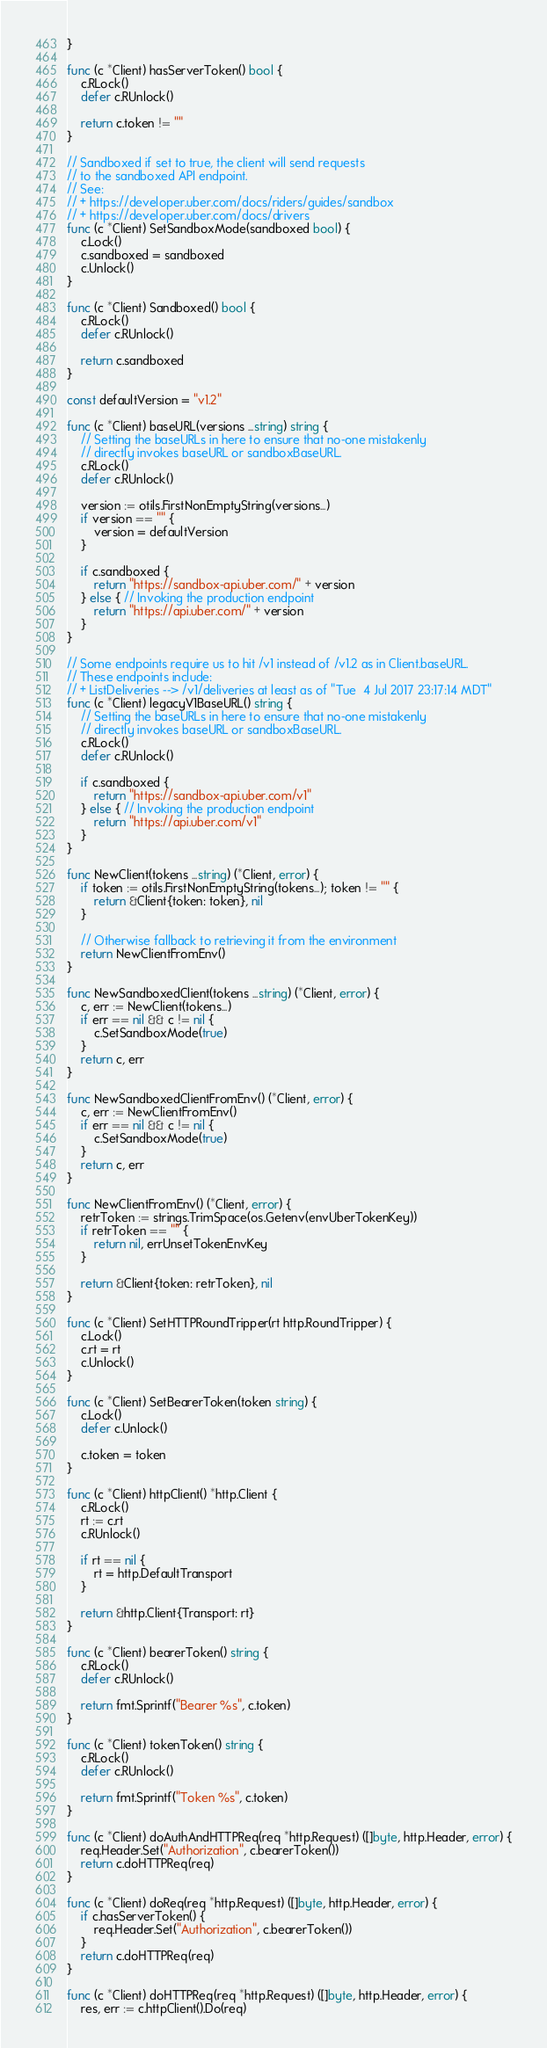<code> <loc_0><loc_0><loc_500><loc_500><_Go_>}

func (c *Client) hasServerToken() bool {
	c.RLock()
	defer c.RUnlock()

	return c.token != ""
}

// Sandboxed if set to true, the client will send requests
// to the sandboxed API endpoint.
// See:
// + https://developer.uber.com/docs/riders/guides/sandbox
// + https://developer.uber.com/docs/drivers
func (c *Client) SetSandboxMode(sandboxed bool) {
	c.Lock()
	c.sandboxed = sandboxed
	c.Unlock()
}

func (c *Client) Sandboxed() bool {
	c.RLock()
	defer c.RUnlock()

	return c.sandboxed
}

const defaultVersion = "v1.2"

func (c *Client) baseURL(versions ...string) string {
	// Setting the baseURLs in here to ensure that no-one mistakenly
	// directly invokes baseURL or sandboxBaseURL.
	c.RLock()
	defer c.RUnlock()

	version := otils.FirstNonEmptyString(versions...)
	if version == "" {
		version = defaultVersion
	}

	if c.sandboxed {
		return "https://sandbox-api.uber.com/" + version
	} else { // Invoking the production endpoint
		return "https://api.uber.com/" + version
	}
}

// Some endpoints require us to hit /v1 instead of /v1.2 as in Client.baseURL.
// These endpoints include:
// + ListDeliveries --> /v1/deliveries at least as of "Tue  4 Jul 2017 23:17:14 MDT"
func (c *Client) legacyV1BaseURL() string {
	// Setting the baseURLs in here to ensure that no-one mistakenly
	// directly invokes baseURL or sandboxBaseURL.
	c.RLock()
	defer c.RUnlock()

	if c.sandboxed {
		return "https://sandbox-api.uber.com/v1"
	} else { // Invoking the production endpoint
		return "https://api.uber.com/v1"
	}
}

func NewClient(tokens ...string) (*Client, error) {
	if token := otils.FirstNonEmptyString(tokens...); token != "" {
		return &Client{token: token}, nil
	}

	// Otherwise fallback to retrieving it from the environment
	return NewClientFromEnv()
}

func NewSandboxedClient(tokens ...string) (*Client, error) {
	c, err := NewClient(tokens...)
	if err == nil && c != nil {
		c.SetSandboxMode(true)
	}
	return c, err
}

func NewSandboxedClientFromEnv() (*Client, error) {
	c, err := NewClientFromEnv()
	if err == nil && c != nil {
		c.SetSandboxMode(true)
	}
	return c, err
}

func NewClientFromEnv() (*Client, error) {
	retrToken := strings.TrimSpace(os.Getenv(envUberTokenKey))
	if retrToken == "" {
		return nil, errUnsetTokenEnvKey
	}

	return &Client{token: retrToken}, nil
}

func (c *Client) SetHTTPRoundTripper(rt http.RoundTripper) {
	c.Lock()
	c.rt = rt
	c.Unlock()
}

func (c *Client) SetBearerToken(token string) {
	c.Lock()
	defer c.Unlock()

	c.token = token
}

func (c *Client) httpClient() *http.Client {
	c.RLock()
	rt := c.rt
	c.RUnlock()

	if rt == nil {
		rt = http.DefaultTransport
	}

	return &http.Client{Transport: rt}
}

func (c *Client) bearerToken() string {
	c.RLock()
	defer c.RUnlock()

	return fmt.Sprintf("Bearer %s", c.token)
}

func (c *Client) tokenToken() string {
	c.RLock()
	defer c.RUnlock()

	return fmt.Sprintf("Token %s", c.token)
}

func (c *Client) doAuthAndHTTPReq(req *http.Request) ([]byte, http.Header, error) {
	req.Header.Set("Authorization", c.bearerToken())
	return c.doHTTPReq(req)
}

func (c *Client) doReq(req *http.Request) ([]byte, http.Header, error) {
	if c.hasServerToken() {
		req.Header.Set("Authorization", c.bearerToken())
	}
	return c.doHTTPReq(req)
}

func (c *Client) doHTTPReq(req *http.Request) ([]byte, http.Header, error) {
	res, err := c.httpClient().Do(req)</code> 